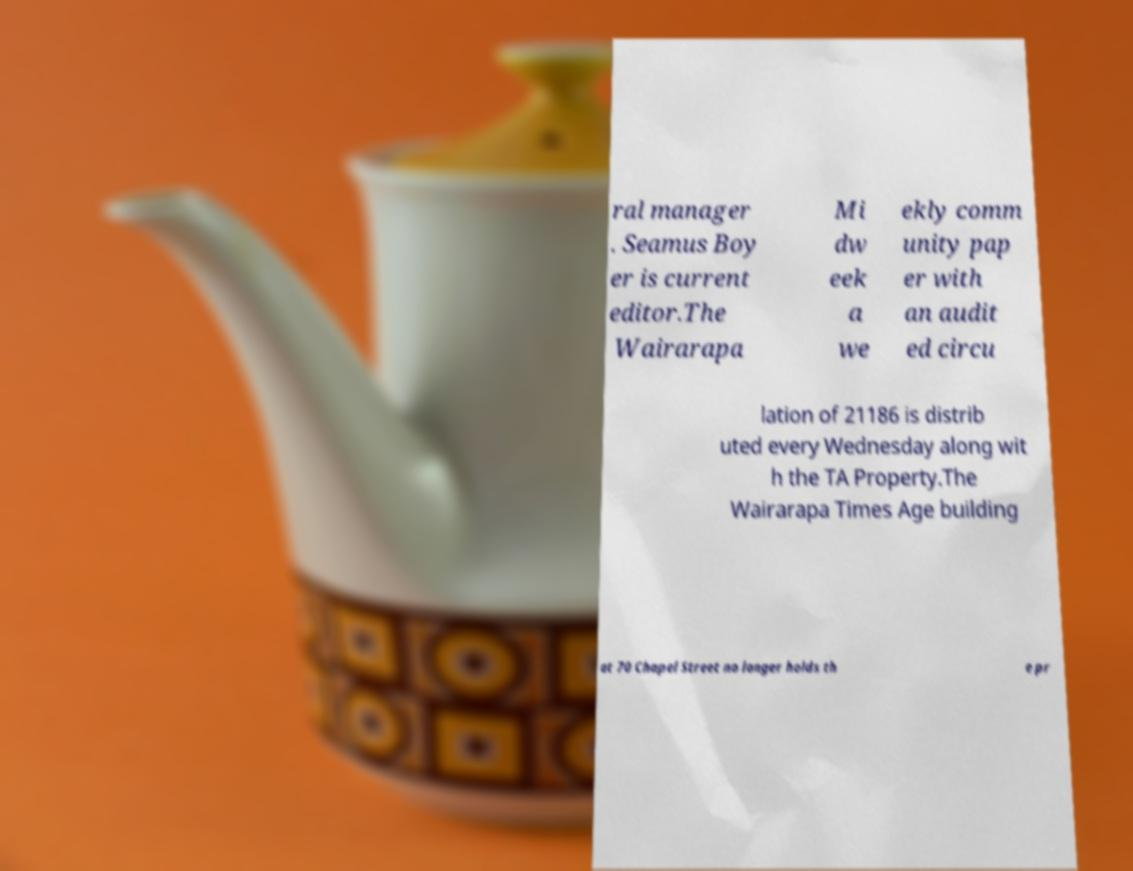Please identify and transcribe the text found in this image. ral manager . Seamus Boy er is current editor.The Wairarapa Mi dw eek a we ekly comm unity pap er with an audit ed circu lation of 21186 is distrib uted every Wednesday along wit h the TA Property.The Wairarapa Times Age building at 70 Chapel Street no longer holds th e pr 